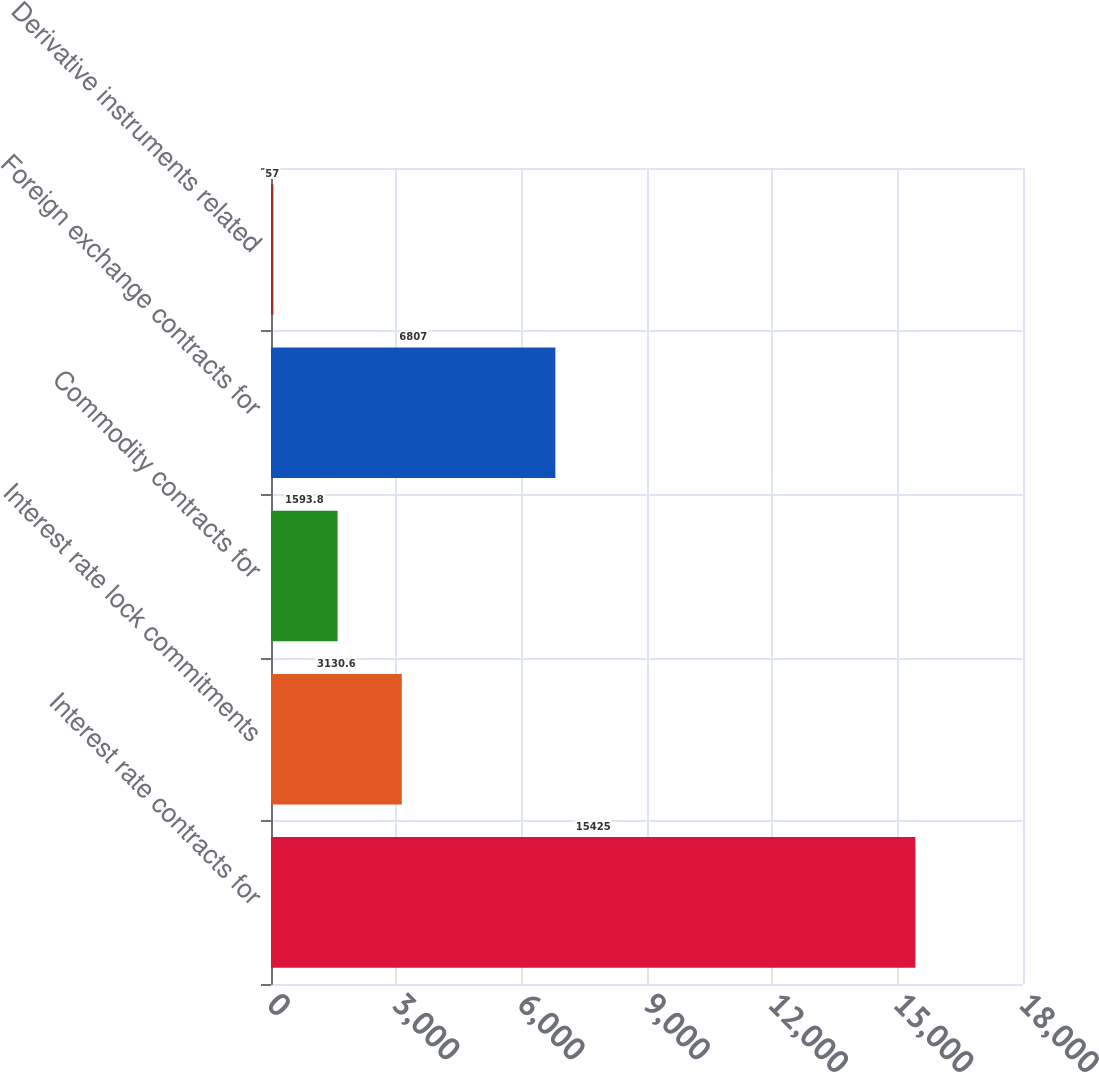Convert chart to OTSL. <chart><loc_0><loc_0><loc_500><loc_500><bar_chart><fcel>Interest rate contracts for<fcel>Interest rate lock commitments<fcel>Commodity contracts for<fcel>Foreign exchange contracts for<fcel>Derivative instruments related<nl><fcel>15425<fcel>3130.6<fcel>1593.8<fcel>6807<fcel>57<nl></chart> 